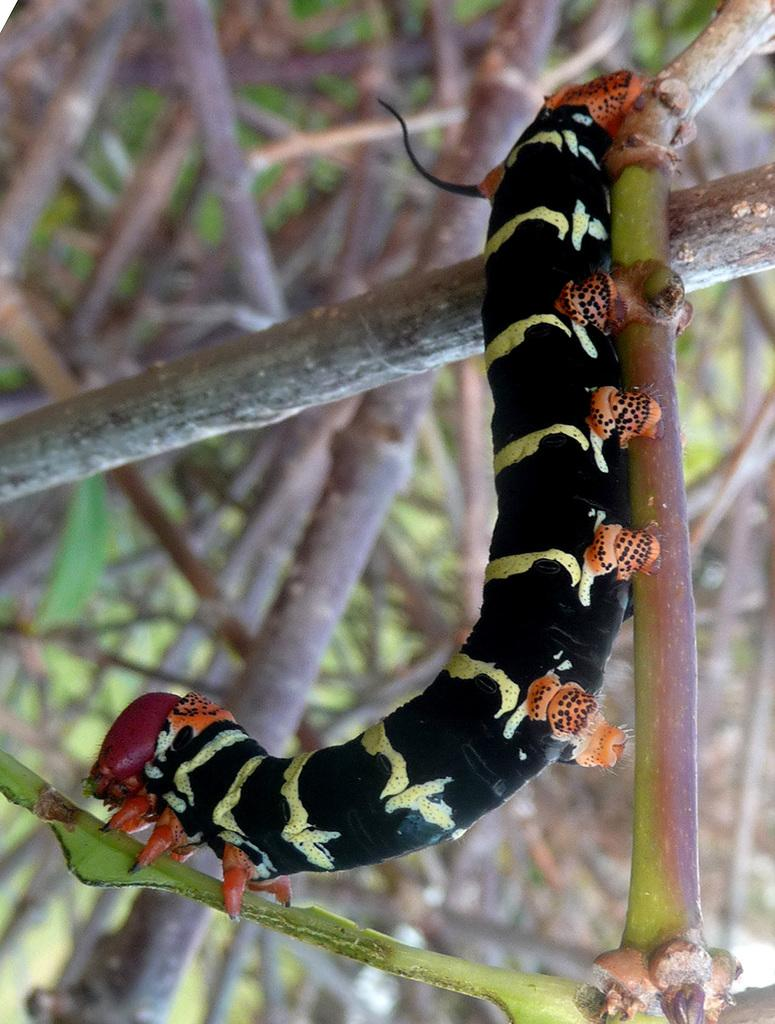What is the main subject of the image? The main subject of the image is a worm. Where is the worm located? The worm is on a tree stem. What can be seen in the background of the image? There are wooden sticks in the background of the image. What type of stocking is the worm wearing in the image? There is no stocking present in the image, and the worm is not wearing any clothing. 